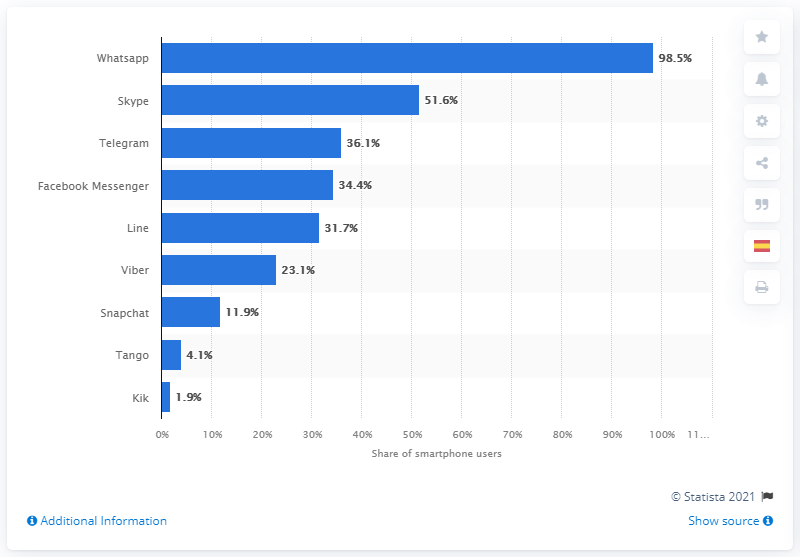Point out several critical features in this image. Whatsapp was the most downloaded app in Spain in 2014. 